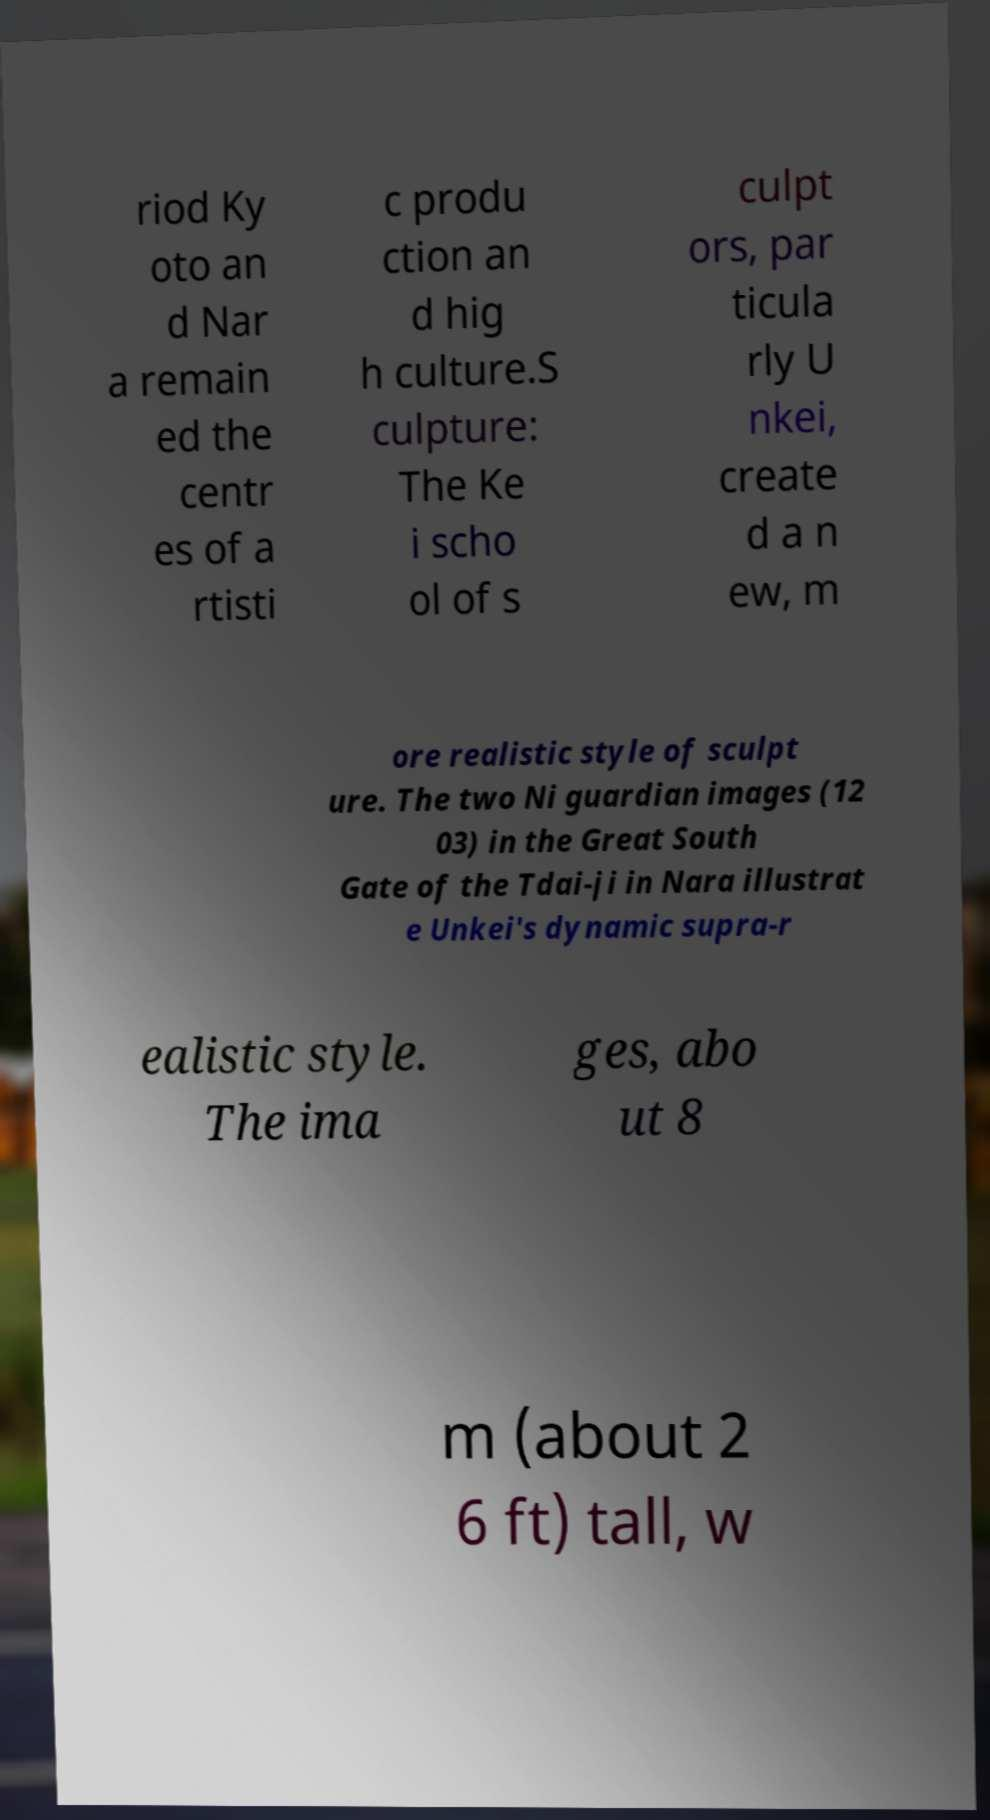Could you extract and type out the text from this image? riod Ky oto an d Nar a remain ed the centr es of a rtisti c produ ction an d hig h culture.S culpture: The Ke i scho ol of s culpt ors, par ticula rly U nkei, create d a n ew, m ore realistic style of sculpt ure. The two Ni guardian images (12 03) in the Great South Gate of the Tdai-ji in Nara illustrat e Unkei's dynamic supra-r ealistic style. The ima ges, abo ut 8 m (about 2 6 ft) tall, w 